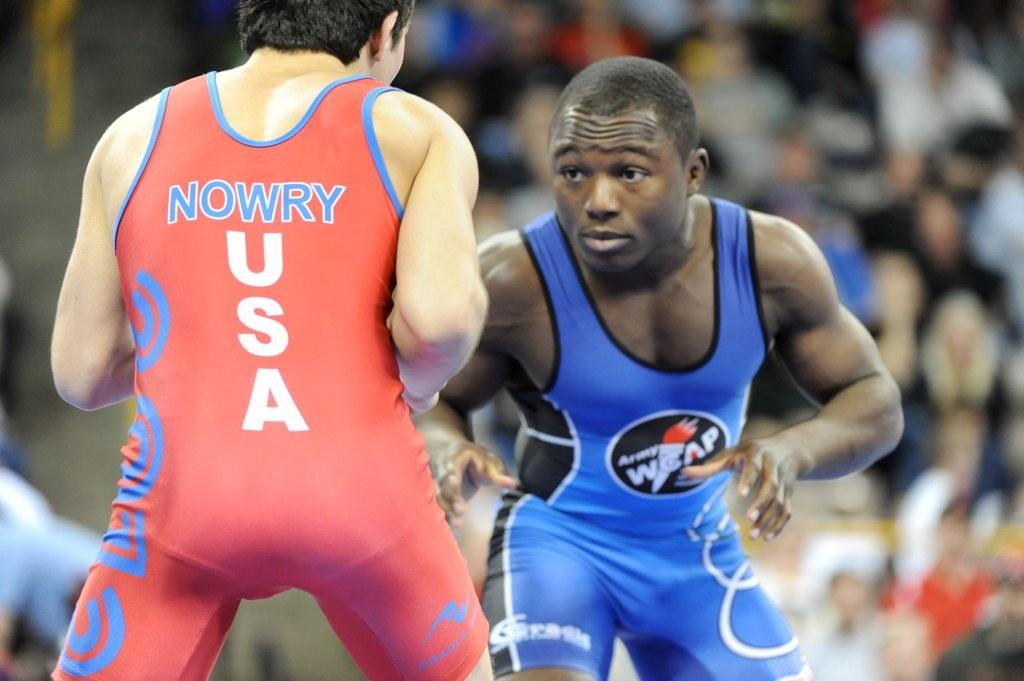<image>
Summarize the visual content of the image. Two men are in a wrestling competition and one represents the USA. 